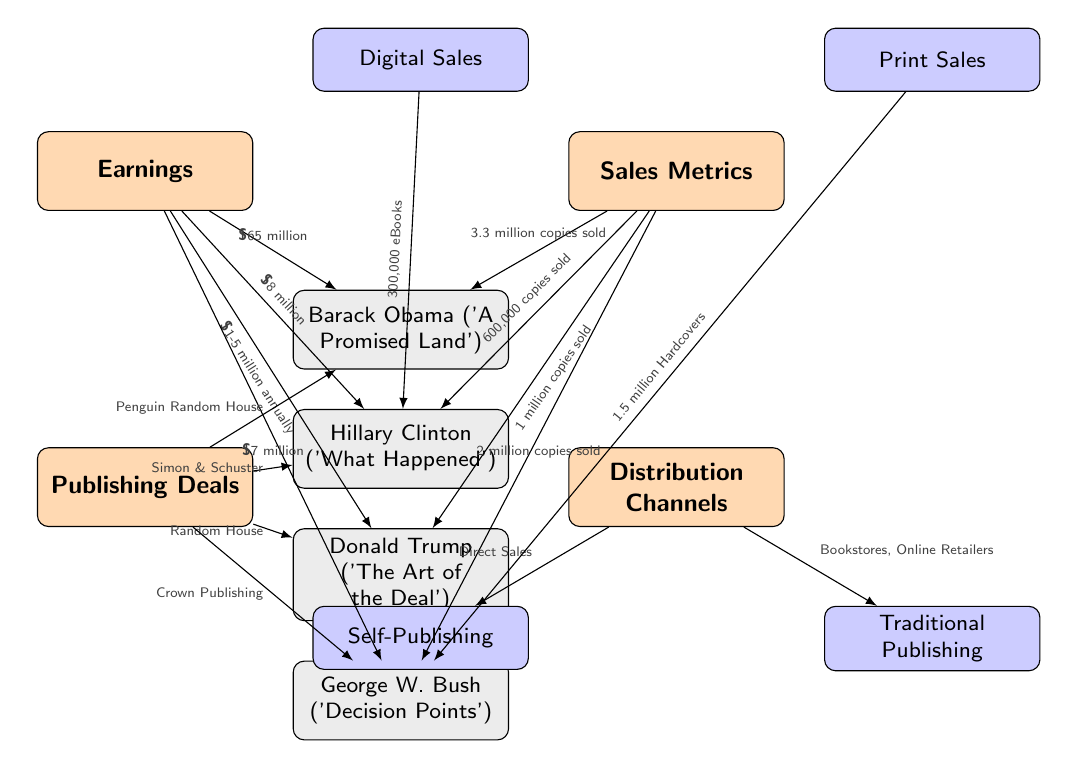What are the earnings for Barack Obama’s memoir? The diagram clearly indicates that Barack Obama earned \$65 million for his memoir 'A Promised Land', as denoted by the edge connecting the earnings category to his name.
Answer: \$65 million How many copies of 'What Happened' were sold? The diagram shows that Hillary Clinton's memoir 'What Happened' sold 600,000 copies, represented by the edge connecting the sales metrics category to her name.
Answer: 600,000 copies sold Which politician had the highest earnings? By comparing the earnings values listed next to each politician, it is evident that Barack Obama had the highest earnings at \$65 million, making him the leader in this metric.
Answer: Barack Obama What is the distribution channel for Hillary Clinton's memoir? The diagram links Hillary Clinton’s memoir to a traditional publishing node, which indicates that she used bookstores and online retailers for distribution.
Answer: Bookstores, Online Retailers How many print sales did George W. Bush’s memoir achieve? The diagram specifies that George W. Bush's memoir had 1.5 million hardcover sales, clearly noted under the print sales metric.
Answer: 1.5 million Hardcovers What is the publishing deal for Donald Trump's memoir? According to the diagram, Donald Trump's memoir 'The Art of the Deal' was published by Random House, which is indicated in the publishing deals section.
Answer: Random House Which memoir sold the most copies? The sales metrics in the diagram show that Barack Obama's memoir sold 3.3 million copies, which is more than the others, making it the best-selling memoir.
Answer: 3.3 million copies sold What are the earnings for Donald Trump’s memoir? The diagram represents Donald Trump’s memoir earnings as \$1-5 million annually, showing the potential revenue that could vary each year.
Answer: \$1-5 million annually What distribution method is associated with self-publishing? The edge connects self-publishing to the direct sales distribution method, indicating that self-publishing authors typically sell their books directly to consumers.
Answer: Direct Sales 